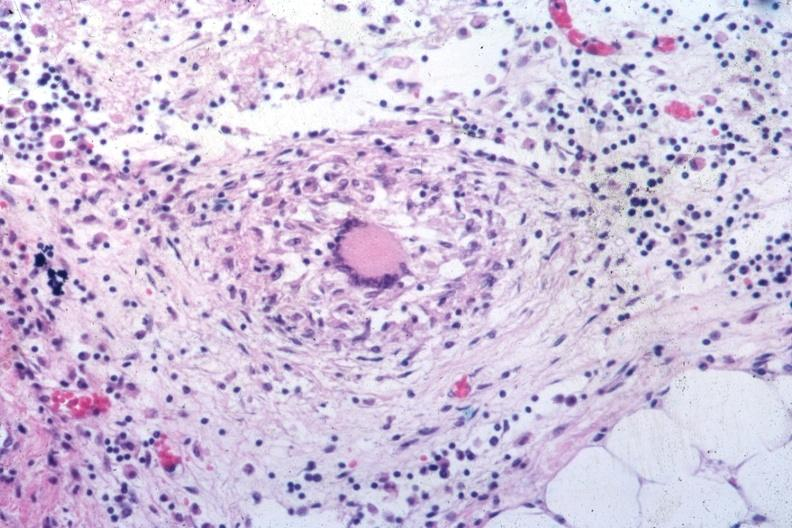does this image show outstanding example of a tubercular granuloma same as in slide seen at low classical granuloma with langhans giant cell?
Answer the question using a single word or phrase. Yes 